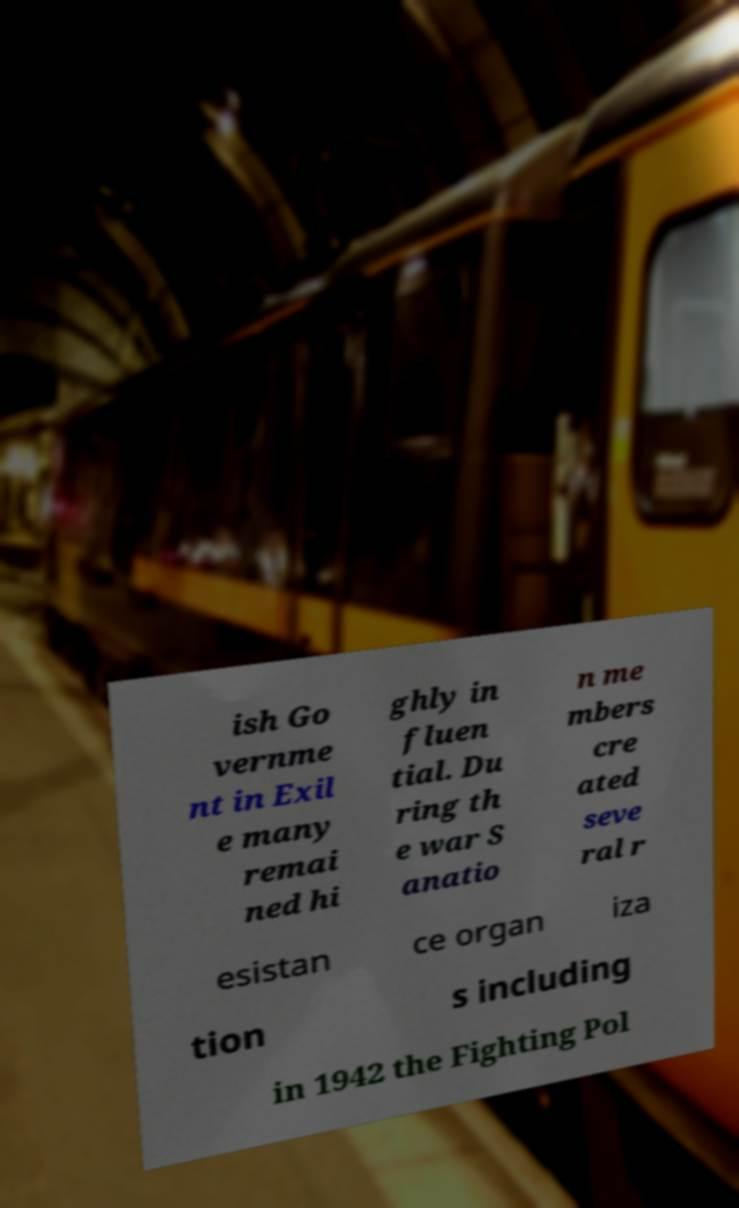Can you accurately transcribe the text from the provided image for me? ish Go vernme nt in Exil e many remai ned hi ghly in fluen tial. Du ring th e war S anatio n me mbers cre ated seve ral r esistan ce organ iza tion s including in 1942 the Fighting Pol 